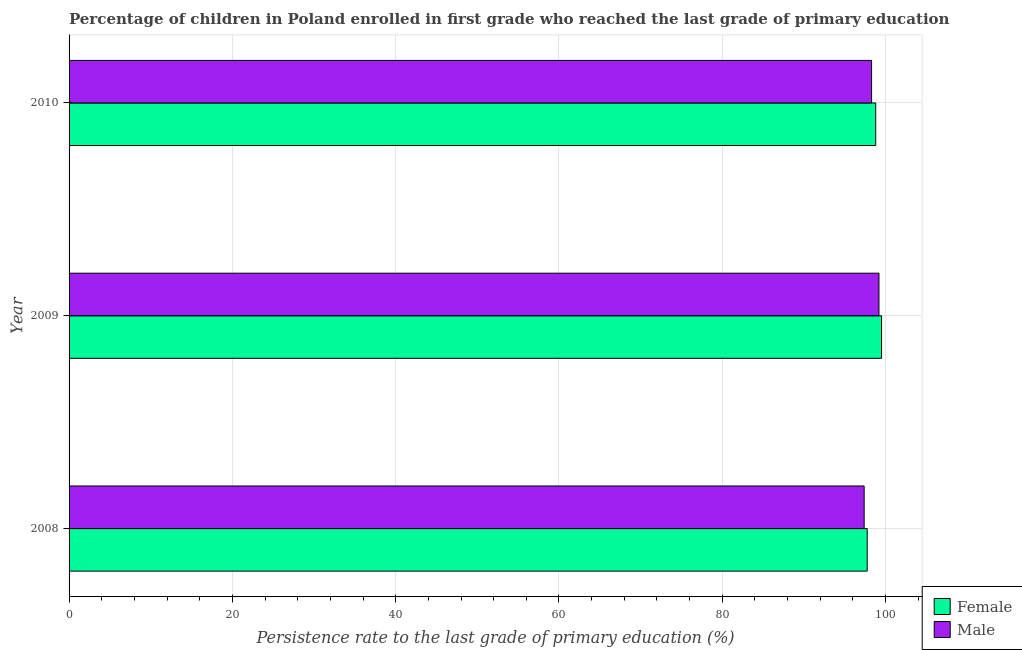How many groups of bars are there?
Offer a terse response. 3. How many bars are there on the 2nd tick from the bottom?
Provide a succinct answer. 2. What is the label of the 3rd group of bars from the top?
Offer a terse response. 2008. In how many cases, is the number of bars for a given year not equal to the number of legend labels?
Make the answer very short. 0. What is the persistence rate of male students in 2010?
Provide a succinct answer. 98.29. Across all years, what is the maximum persistence rate of male students?
Your answer should be compact. 99.19. Across all years, what is the minimum persistence rate of female students?
Offer a very short reply. 97.75. What is the total persistence rate of male students in the graph?
Keep it short and to the point. 294.85. What is the difference between the persistence rate of female students in 2009 and that in 2010?
Your response must be concise. 0.72. What is the difference between the persistence rate of male students in 2010 and the persistence rate of female students in 2009?
Your response must be concise. -1.22. What is the average persistence rate of male students per year?
Ensure brevity in your answer.  98.28. In the year 2010, what is the difference between the persistence rate of male students and persistence rate of female students?
Your response must be concise. -0.51. What is the ratio of the persistence rate of male students in 2008 to that in 2010?
Your answer should be compact. 0.99. Is the difference between the persistence rate of male students in 2009 and 2010 greater than the difference between the persistence rate of female students in 2009 and 2010?
Provide a succinct answer. Yes. What is the difference between the highest and the second highest persistence rate of female students?
Your response must be concise. 0.72. What is the difference between the highest and the lowest persistence rate of male students?
Your answer should be very brief. 1.81. In how many years, is the persistence rate of male students greater than the average persistence rate of male students taken over all years?
Your answer should be compact. 2. Is the sum of the persistence rate of male students in 2008 and 2009 greater than the maximum persistence rate of female students across all years?
Offer a terse response. Yes. What does the 1st bar from the top in 2009 represents?
Your response must be concise. Male. What does the 1st bar from the bottom in 2009 represents?
Make the answer very short. Female. Does the graph contain any zero values?
Make the answer very short. No. How many legend labels are there?
Your answer should be compact. 2. What is the title of the graph?
Keep it short and to the point. Percentage of children in Poland enrolled in first grade who reached the last grade of primary education. Does "Highest 10% of population" appear as one of the legend labels in the graph?
Ensure brevity in your answer.  No. What is the label or title of the X-axis?
Provide a short and direct response. Persistence rate to the last grade of primary education (%). What is the Persistence rate to the last grade of primary education (%) of Female in 2008?
Your answer should be compact. 97.75. What is the Persistence rate to the last grade of primary education (%) of Male in 2008?
Provide a succinct answer. 97.38. What is the Persistence rate to the last grade of primary education (%) of Female in 2009?
Your answer should be compact. 99.51. What is the Persistence rate to the last grade of primary education (%) in Male in 2009?
Offer a terse response. 99.19. What is the Persistence rate to the last grade of primary education (%) of Female in 2010?
Your answer should be very brief. 98.79. What is the Persistence rate to the last grade of primary education (%) in Male in 2010?
Provide a short and direct response. 98.29. Across all years, what is the maximum Persistence rate to the last grade of primary education (%) of Female?
Give a very brief answer. 99.51. Across all years, what is the maximum Persistence rate to the last grade of primary education (%) of Male?
Provide a short and direct response. 99.19. Across all years, what is the minimum Persistence rate to the last grade of primary education (%) of Female?
Provide a short and direct response. 97.75. Across all years, what is the minimum Persistence rate to the last grade of primary education (%) in Male?
Offer a terse response. 97.38. What is the total Persistence rate to the last grade of primary education (%) of Female in the graph?
Ensure brevity in your answer.  296.05. What is the total Persistence rate to the last grade of primary education (%) in Male in the graph?
Offer a terse response. 294.85. What is the difference between the Persistence rate to the last grade of primary education (%) of Female in 2008 and that in 2009?
Offer a terse response. -1.76. What is the difference between the Persistence rate to the last grade of primary education (%) in Male in 2008 and that in 2009?
Your response must be concise. -1.81. What is the difference between the Persistence rate to the last grade of primary education (%) of Female in 2008 and that in 2010?
Offer a terse response. -1.04. What is the difference between the Persistence rate to the last grade of primary education (%) in Male in 2008 and that in 2010?
Provide a succinct answer. -0.91. What is the difference between the Persistence rate to the last grade of primary education (%) of Female in 2009 and that in 2010?
Your answer should be compact. 0.72. What is the difference between the Persistence rate to the last grade of primary education (%) in Male in 2009 and that in 2010?
Ensure brevity in your answer.  0.9. What is the difference between the Persistence rate to the last grade of primary education (%) in Female in 2008 and the Persistence rate to the last grade of primary education (%) in Male in 2009?
Offer a very short reply. -1.44. What is the difference between the Persistence rate to the last grade of primary education (%) of Female in 2008 and the Persistence rate to the last grade of primary education (%) of Male in 2010?
Keep it short and to the point. -0.54. What is the difference between the Persistence rate to the last grade of primary education (%) of Female in 2009 and the Persistence rate to the last grade of primary education (%) of Male in 2010?
Offer a terse response. 1.22. What is the average Persistence rate to the last grade of primary education (%) in Female per year?
Provide a succinct answer. 98.68. What is the average Persistence rate to the last grade of primary education (%) of Male per year?
Provide a succinct answer. 98.28. In the year 2008, what is the difference between the Persistence rate to the last grade of primary education (%) in Female and Persistence rate to the last grade of primary education (%) in Male?
Your response must be concise. 0.37. In the year 2009, what is the difference between the Persistence rate to the last grade of primary education (%) of Female and Persistence rate to the last grade of primary education (%) of Male?
Offer a very short reply. 0.32. In the year 2010, what is the difference between the Persistence rate to the last grade of primary education (%) in Female and Persistence rate to the last grade of primary education (%) in Male?
Your answer should be compact. 0.51. What is the ratio of the Persistence rate to the last grade of primary education (%) in Female in 2008 to that in 2009?
Offer a terse response. 0.98. What is the ratio of the Persistence rate to the last grade of primary education (%) of Male in 2008 to that in 2009?
Offer a terse response. 0.98. What is the ratio of the Persistence rate to the last grade of primary education (%) of Female in 2008 to that in 2010?
Offer a very short reply. 0.99. What is the ratio of the Persistence rate to the last grade of primary education (%) in Female in 2009 to that in 2010?
Your answer should be very brief. 1.01. What is the ratio of the Persistence rate to the last grade of primary education (%) of Male in 2009 to that in 2010?
Keep it short and to the point. 1.01. What is the difference between the highest and the second highest Persistence rate to the last grade of primary education (%) of Female?
Your answer should be very brief. 0.72. What is the difference between the highest and the second highest Persistence rate to the last grade of primary education (%) in Male?
Make the answer very short. 0.9. What is the difference between the highest and the lowest Persistence rate to the last grade of primary education (%) in Female?
Make the answer very short. 1.76. What is the difference between the highest and the lowest Persistence rate to the last grade of primary education (%) in Male?
Offer a very short reply. 1.81. 